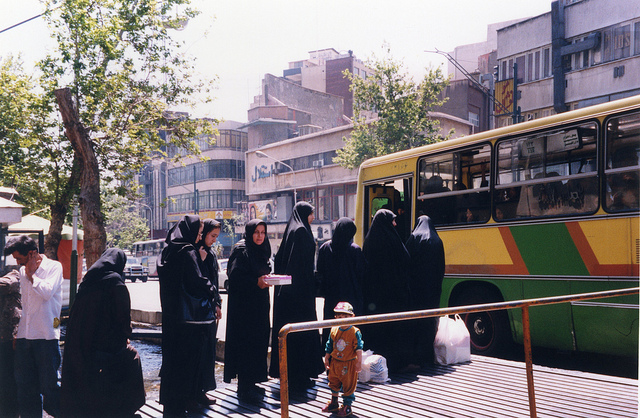Identify the text contained in this image. E IOS 